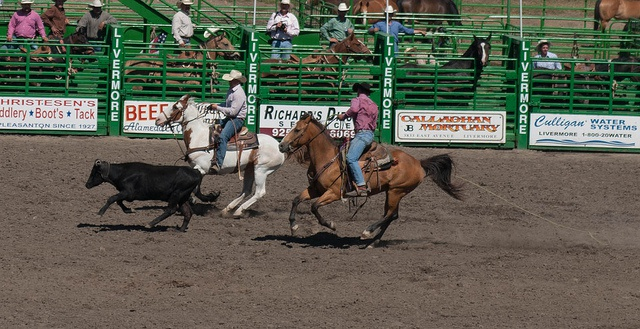Describe the objects in this image and their specific colors. I can see horse in darkgray, black, maroon, and brown tones, horse in darkgray, lightgray, gray, and black tones, cow in darkgray, black, and gray tones, horse in darkgray, black, darkgreen, gray, and green tones, and horse in darkgray, black, darkgreen, maroon, and gray tones in this image. 